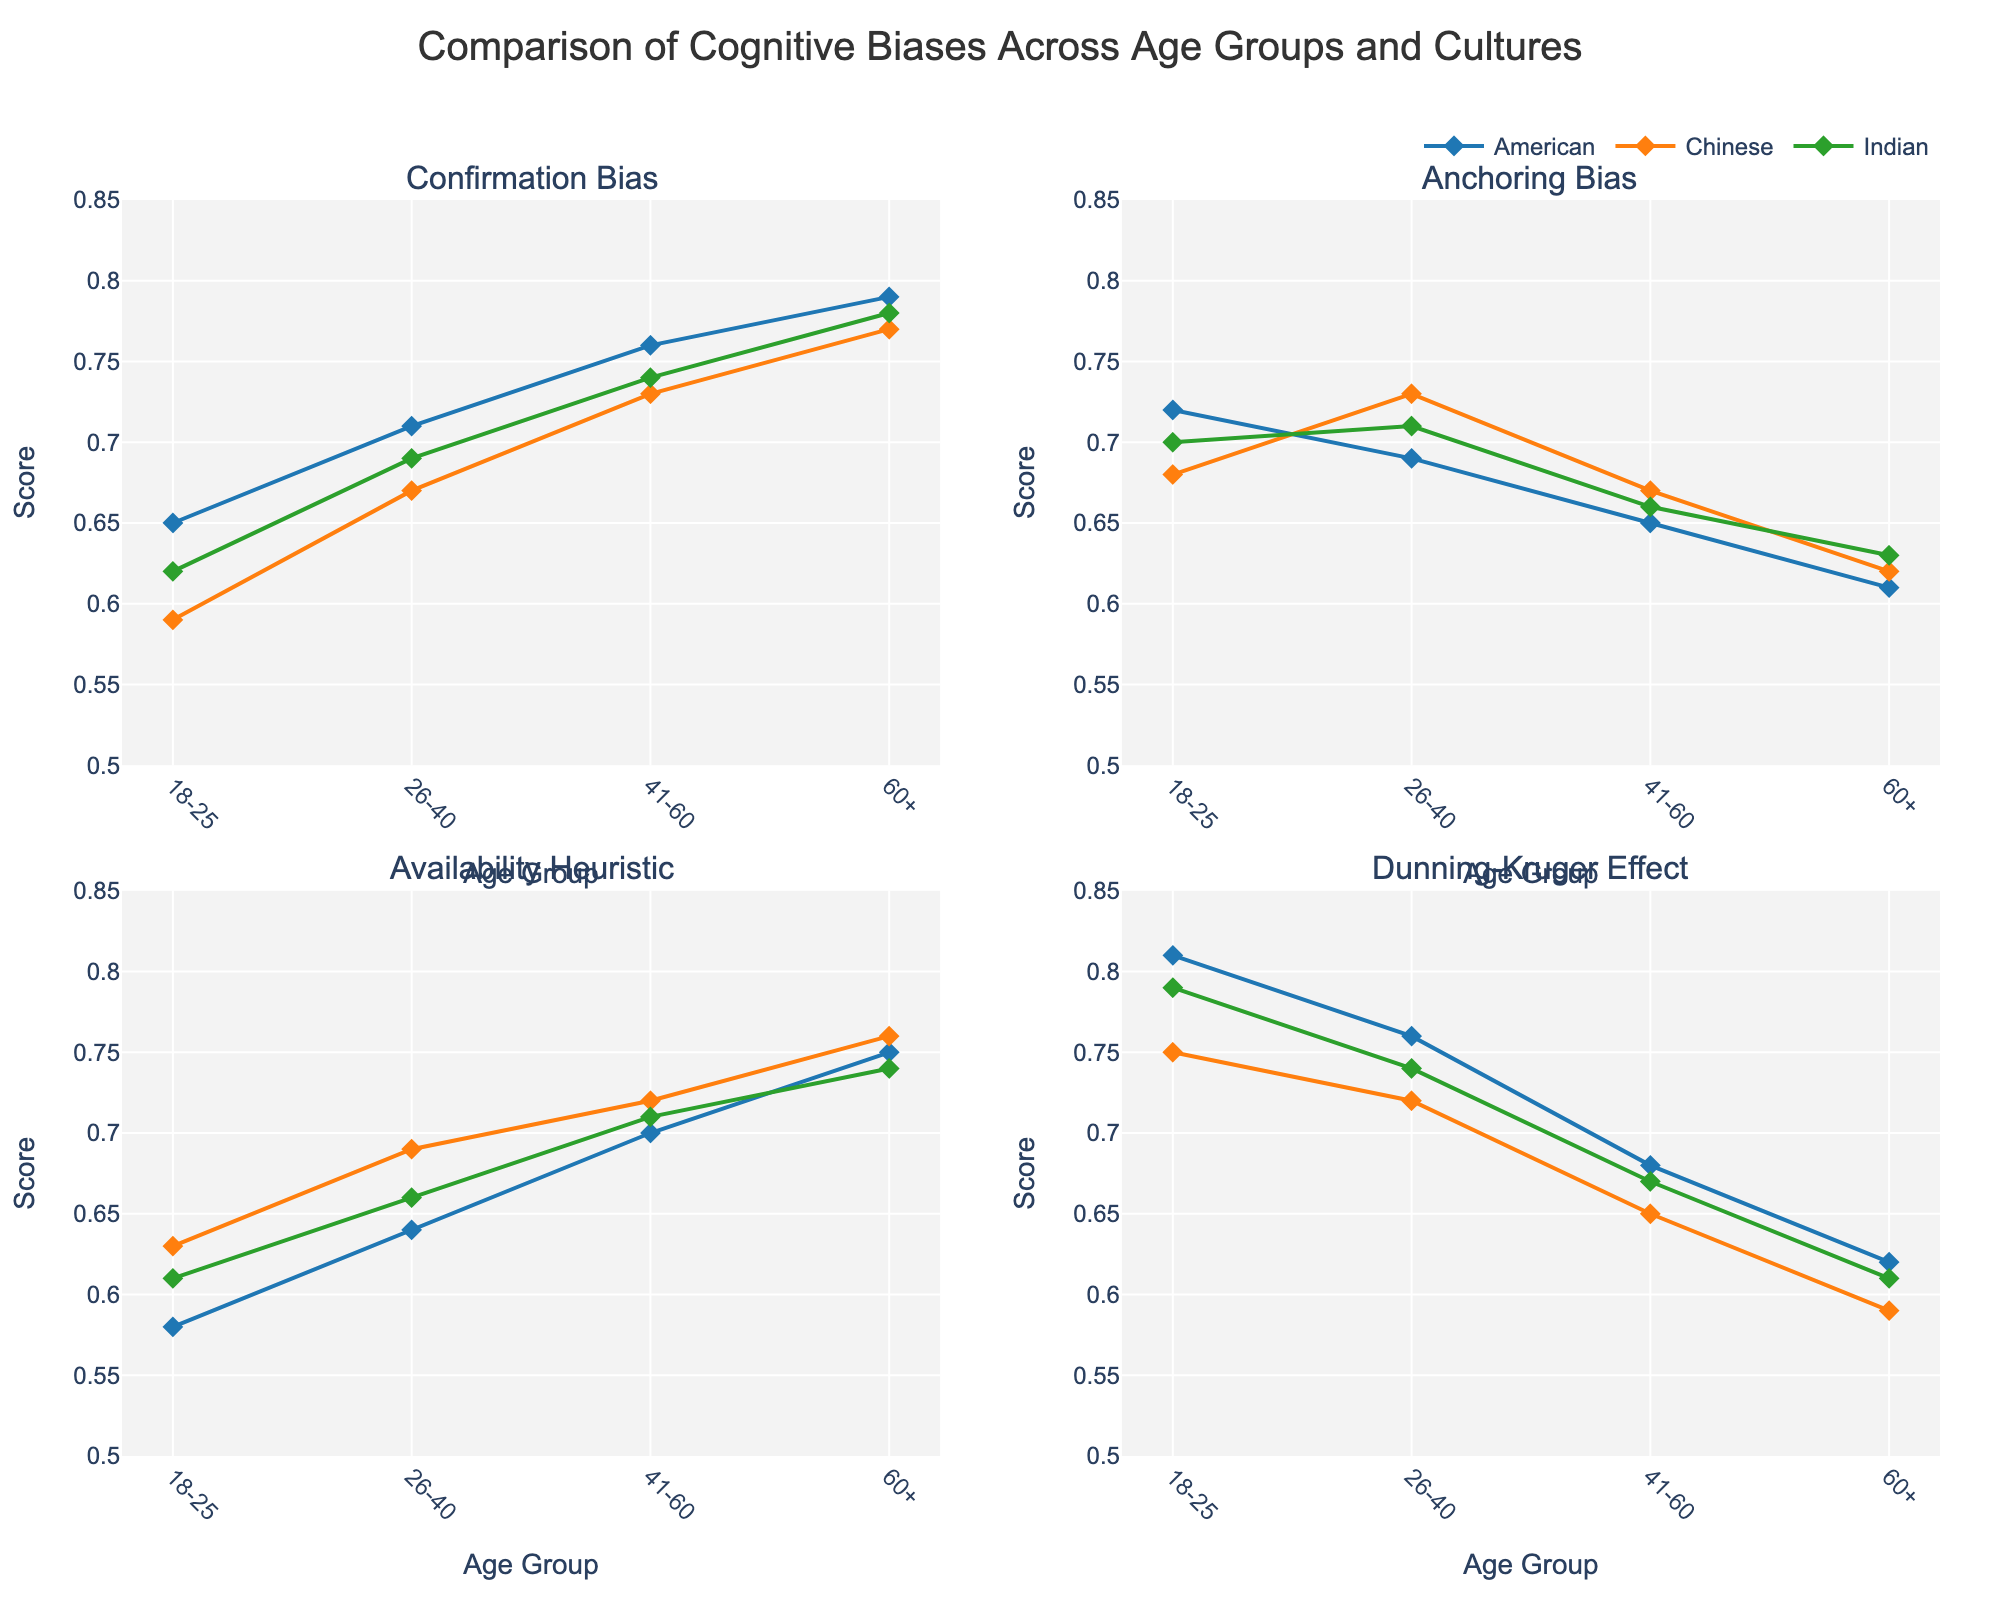What is the title of the figure? The title is usually the main descriptor of the content of the figure, often found at the top. In this case, the title text is clearly specified in the layout update section.
Answer: Comparison of Cognitive Biases Across Age Groups and Cultures How many different culture groups are compared in the figure? The figure includes multiple lines for different cultures, each indicated by different colors and labels visible in the legend. The distinct cultures in the legend are American, Chinese, and Indian.
Answer: 3 In which age group is the Confirmation Bias highest among American participants? To determine this, look at the subplot for Confirmation Bias and identify the line segment marked for Americans. The highest value on this line segment falls within the age group 60+.
Answer: 60+ Which culture group has the lowest score for Availability Heuristic in the age group 41-60? Examine the subplot for Availability Heuristic and locate the data points for the age group 41-60. Compare the values for each culture group and identify the lowest value. The Chinese participants have the lowest score.
Answer: Chinese Compare the Dunning-Kruger Effect scores for the age group 18-25 between American and Indian participants. Which group has a higher score? To compare, find the subplot for the Dunning-Kruger Effect and locate the values for the age group 18-25 for both American and Indian lines. The American score is 0.81 and the Indian score is 0.79.
Answer: American What is the average Confirmation Bias score for the culture groups in the age group 26-40? To find the average, locate the Confirmation Bias values for the age group 26-40 across all cultures: American (0.71), Chinese (0.67), and Indian (0.69). Calculate the average: (0.71 + 0.67 + 0.69)/3 = 0.69.
Answer: 0.69 Which age group shows the smallest difference in Anchoring Bias between American and Indian participants? Locate the Anchoring Bias values for each age group and calculate the differences: 
18-25 (0.72 - 0.70 = 0.02), 
26-40 (0.69 - 0.71 = -0.02), 
41-60 (0.65 - 0.66 = -0.01),
60+ (0.61 - 0.63 = -0.02). The smallest absolute difference is for age group 41-60.
Answer: 41-60 Which cognitive bias shows the least variation across all age groups for Chinese participants? For each bias subplot, look at the range of values for Chinese participants across all age groups and compare the differences:
Confirmation Bias (0.59 to 0.77 = 0.18),
Anchoring Bias (0.62 to 0.73 = 0.11),
Availability Heuristic (0.63 to 0.76 = 0.13),
Dunning-Kruger Effect (0.59 to 0.75 = 0.16). Anchoring Bias shows the least variation.
Answer: Anchoring Bias 